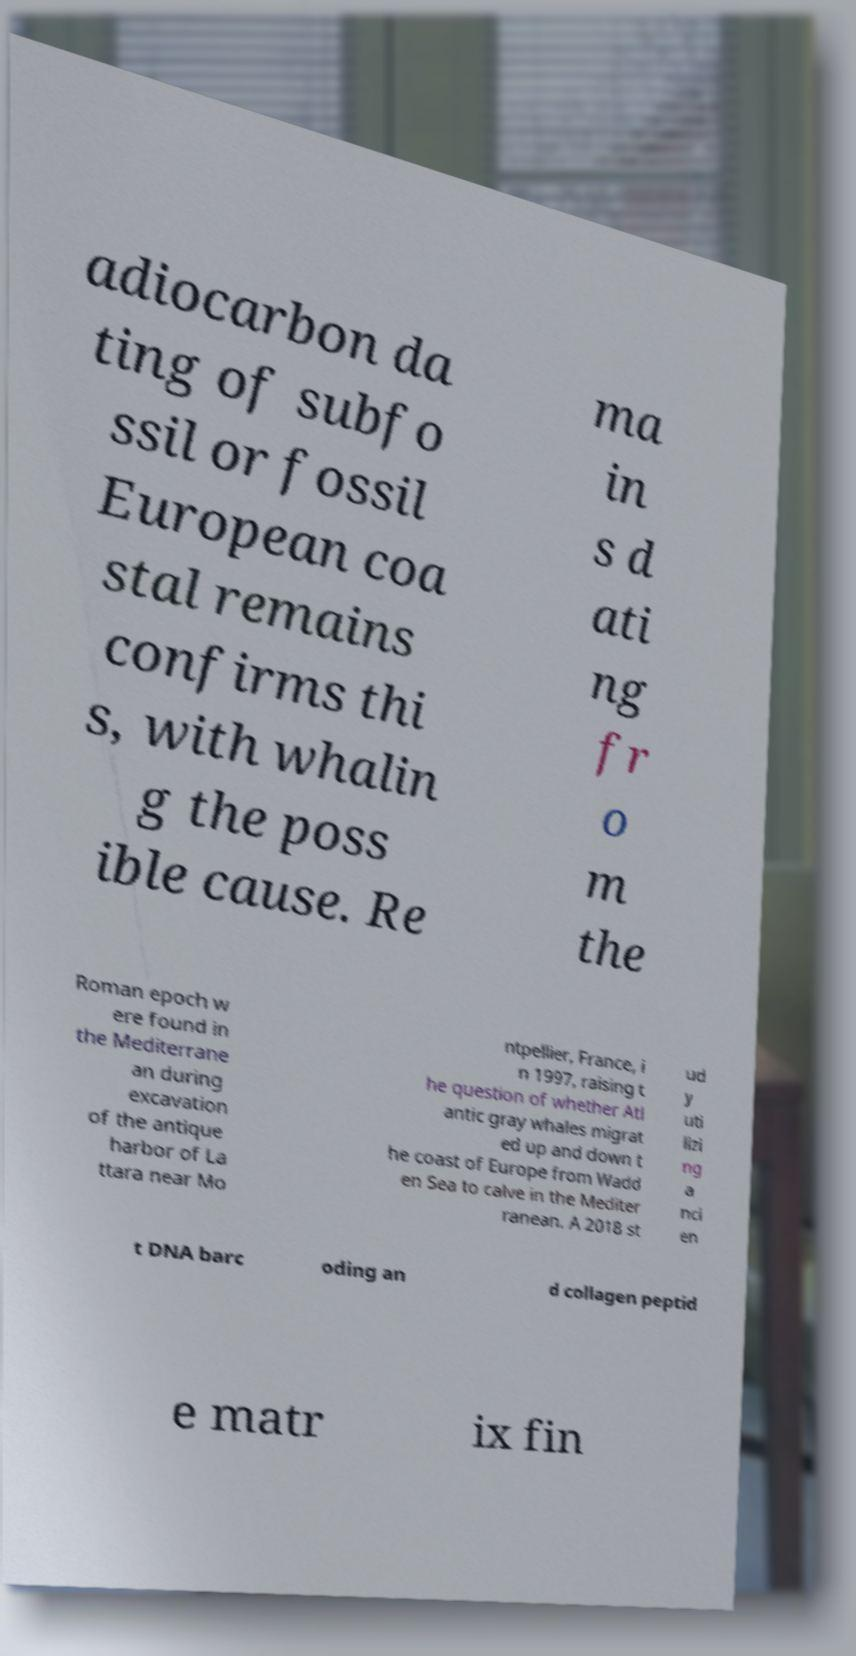For documentation purposes, I need the text within this image transcribed. Could you provide that? adiocarbon da ting of subfo ssil or fossil European coa stal remains confirms thi s, with whalin g the poss ible cause. Re ma in s d ati ng fr o m the Roman epoch w ere found in the Mediterrane an during excavation of the antique harbor of La ttara near Mo ntpellier, France, i n 1997, raising t he question of whether Atl antic gray whales migrat ed up and down t he coast of Europe from Wadd en Sea to calve in the Mediter ranean. A 2018 st ud y uti lizi ng a nci en t DNA barc oding an d collagen peptid e matr ix fin 